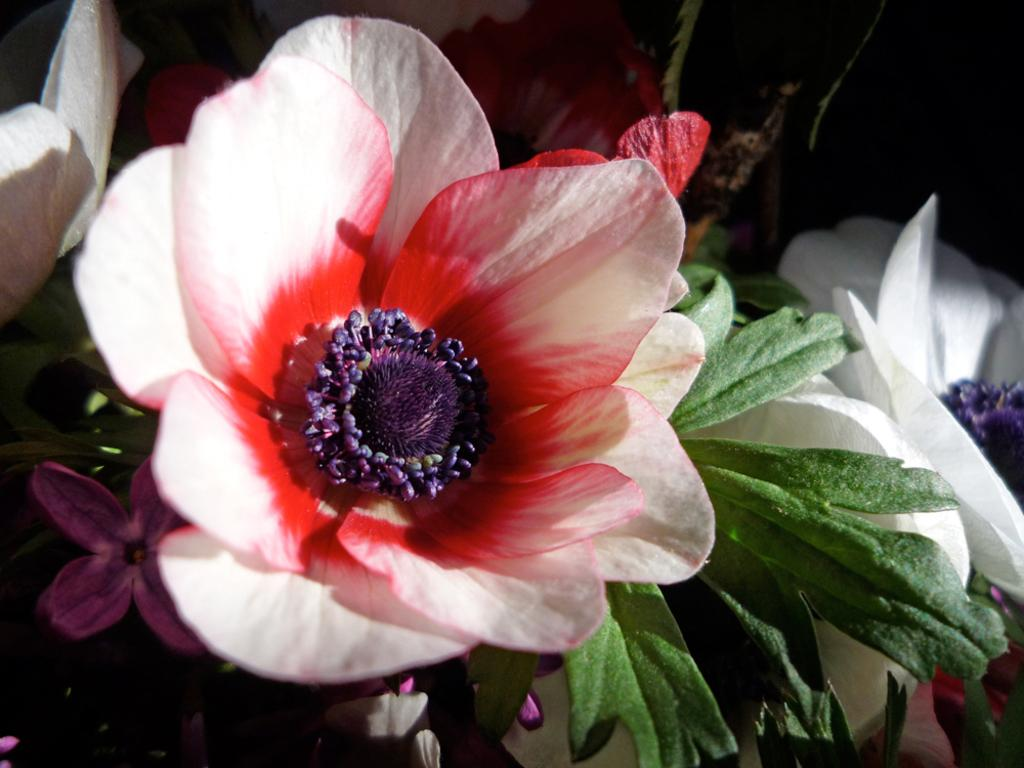What type of plant life is visible in the image? There are flowers and leaves in the image. Can you describe the flowers in the image? Unfortunately, the facts provided do not give specific details about the flowers. What is the general context of the image? The image features plant life, specifically flowers and leaves. Is the quicksand visible in the image? There is no mention of quicksand in the provided facts, and it is not visible in the image. What time of day is depicted in the image? The provided facts do not give any information about the time of day, so it cannot be determined from the image. 